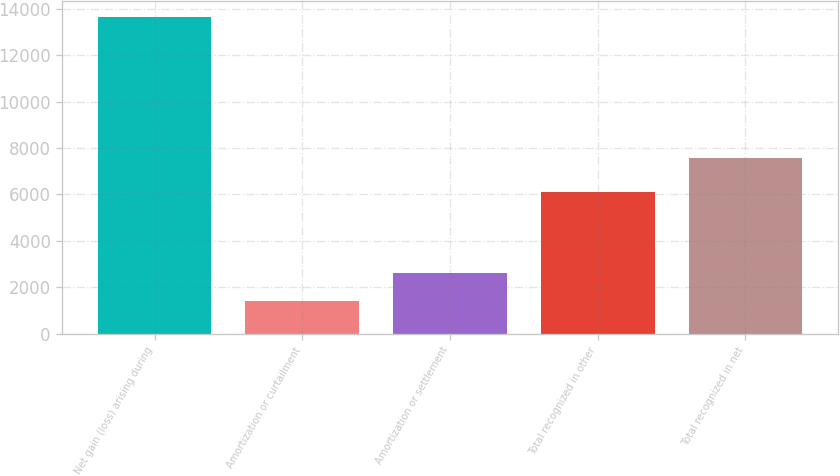Convert chart to OTSL. <chart><loc_0><loc_0><loc_500><loc_500><bar_chart><fcel>Net gain (loss) arising during<fcel>Amortization or curtailment<fcel>Amortization or settlement<fcel>Total recognized in other<fcel>Total recognized in net<nl><fcel>13655<fcel>1388<fcel>2614.7<fcel>6092<fcel>7575<nl></chart> 